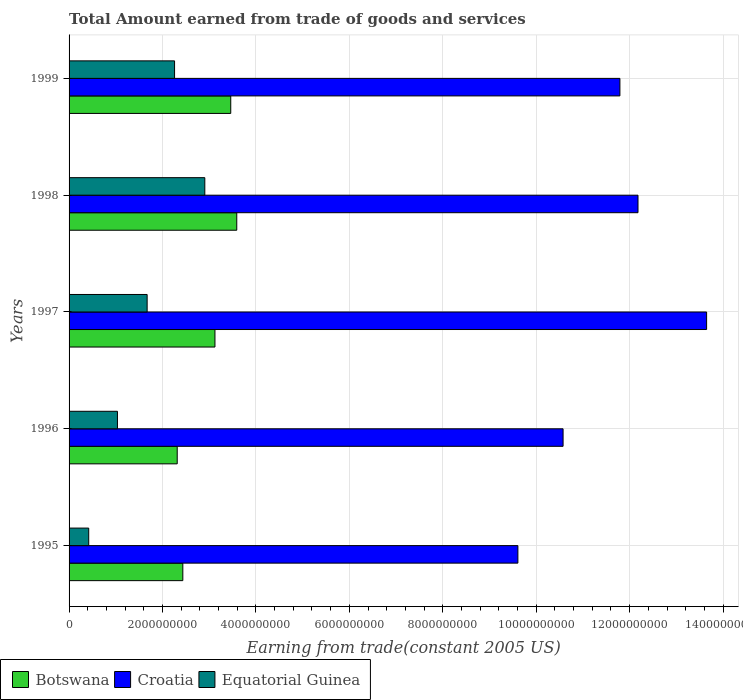How many different coloured bars are there?
Your answer should be very brief. 3. Are the number of bars on each tick of the Y-axis equal?
Your answer should be compact. Yes. What is the label of the 1st group of bars from the top?
Keep it short and to the point. 1999. What is the total amount earned by trading goods and services in Croatia in 1999?
Keep it short and to the point. 1.18e+1. Across all years, what is the maximum total amount earned by trading goods and services in Botswana?
Your answer should be compact. 3.59e+09. Across all years, what is the minimum total amount earned by trading goods and services in Equatorial Guinea?
Provide a short and direct response. 4.21e+08. In which year was the total amount earned by trading goods and services in Equatorial Guinea maximum?
Provide a succinct answer. 1998. In which year was the total amount earned by trading goods and services in Croatia minimum?
Provide a short and direct response. 1995. What is the total total amount earned by trading goods and services in Botswana in the graph?
Provide a succinct answer. 1.49e+1. What is the difference between the total amount earned by trading goods and services in Equatorial Guinea in 1998 and that in 1999?
Offer a very short reply. 6.48e+08. What is the difference between the total amount earned by trading goods and services in Botswana in 1996 and the total amount earned by trading goods and services in Croatia in 1998?
Your answer should be very brief. -9.86e+09. What is the average total amount earned by trading goods and services in Croatia per year?
Provide a succinct answer. 1.16e+1. In the year 1997, what is the difference between the total amount earned by trading goods and services in Botswana and total amount earned by trading goods and services in Croatia?
Your answer should be very brief. -1.05e+1. What is the ratio of the total amount earned by trading goods and services in Croatia in 1996 to that in 1997?
Provide a succinct answer. 0.77. Is the total amount earned by trading goods and services in Equatorial Guinea in 1997 less than that in 1998?
Ensure brevity in your answer.  Yes. Is the difference between the total amount earned by trading goods and services in Botswana in 1995 and 1999 greater than the difference between the total amount earned by trading goods and services in Croatia in 1995 and 1999?
Make the answer very short. Yes. What is the difference between the highest and the second highest total amount earned by trading goods and services in Equatorial Guinea?
Offer a very short reply. 6.48e+08. What is the difference between the highest and the lowest total amount earned by trading goods and services in Botswana?
Offer a terse response. 1.27e+09. In how many years, is the total amount earned by trading goods and services in Croatia greater than the average total amount earned by trading goods and services in Croatia taken over all years?
Provide a succinct answer. 3. Is the sum of the total amount earned by trading goods and services in Equatorial Guinea in 1997 and 1999 greater than the maximum total amount earned by trading goods and services in Croatia across all years?
Offer a very short reply. No. What does the 2nd bar from the top in 1997 represents?
Make the answer very short. Croatia. What does the 2nd bar from the bottom in 1998 represents?
Your answer should be compact. Croatia. Is it the case that in every year, the sum of the total amount earned by trading goods and services in Equatorial Guinea and total amount earned by trading goods and services in Botswana is greater than the total amount earned by trading goods and services in Croatia?
Your answer should be very brief. No. How many bars are there?
Provide a short and direct response. 15. Are all the bars in the graph horizontal?
Make the answer very short. Yes. What is the difference between two consecutive major ticks on the X-axis?
Make the answer very short. 2.00e+09. Are the values on the major ticks of X-axis written in scientific E-notation?
Your response must be concise. No. Does the graph contain any zero values?
Offer a very short reply. No. What is the title of the graph?
Make the answer very short. Total Amount earned from trade of goods and services. What is the label or title of the X-axis?
Give a very brief answer. Earning from trade(constant 2005 US). What is the label or title of the Y-axis?
Keep it short and to the point. Years. What is the Earning from trade(constant 2005 US) in Botswana in 1995?
Your answer should be very brief. 2.44e+09. What is the Earning from trade(constant 2005 US) of Croatia in 1995?
Offer a very short reply. 9.61e+09. What is the Earning from trade(constant 2005 US) in Equatorial Guinea in 1995?
Your response must be concise. 4.21e+08. What is the Earning from trade(constant 2005 US) of Botswana in 1996?
Offer a very short reply. 2.32e+09. What is the Earning from trade(constant 2005 US) in Croatia in 1996?
Keep it short and to the point. 1.06e+1. What is the Earning from trade(constant 2005 US) of Equatorial Guinea in 1996?
Keep it short and to the point. 1.04e+09. What is the Earning from trade(constant 2005 US) in Botswana in 1997?
Provide a succinct answer. 3.12e+09. What is the Earning from trade(constant 2005 US) in Croatia in 1997?
Provide a short and direct response. 1.36e+1. What is the Earning from trade(constant 2005 US) in Equatorial Guinea in 1997?
Your answer should be very brief. 1.67e+09. What is the Earning from trade(constant 2005 US) in Botswana in 1998?
Offer a terse response. 3.59e+09. What is the Earning from trade(constant 2005 US) in Croatia in 1998?
Provide a succinct answer. 1.22e+1. What is the Earning from trade(constant 2005 US) of Equatorial Guinea in 1998?
Make the answer very short. 2.91e+09. What is the Earning from trade(constant 2005 US) in Botswana in 1999?
Ensure brevity in your answer.  3.46e+09. What is the Earning from trade(constant 2005 US) of Croatia in 1999?
Keep it short and to the point. 1.18e+1. What is the Earning from trade(constant 2005 US) of Equatorial Guinea in 1999?
Give a very brief answer. 2.26e+09. Across all years, what is the maximum Earning from trade(constant 2005 US) of Botswana?
Keep it short and to the point. 3.59e+09. Across all years, what is the maximum Earning from trade(constant 2005 US) of Croatia?
Ensure brevity in your answer.  1.36e+1. Across all years, what is the maximum Earning from trade(constant 2005 US) in Equatorial Guinea?
Give a very brief answer. 2.91e+09. Across all years, what is the minimum Earning from trade(constant 2005 US) in Botswana?
Keep it short and to the point. 2.32e+09. Across all years, what is the minimum Earning from trade(constant 2005 US) of Croatia?
Your response must be concise. 9.61e+09. Across all years, what is the minimum Earning from trade(constant 2005 US) in Equatorial Guinea?
Your answer should be very brief. 4.21e+08. What is the total Earning from trade(constant 2005 US) of Botswana in the graph?
Keep it short and to the point. 1.49e+1. What is the total Earning from trade(constant 2005 US) in Croatia in the graph?
Give a very brief answer. 5.78e+1. What is the total Earning from trade(constant 2005 US) of Equatorial Guinea in the graph?
Your response must be concise. 8.29e+09. What is the difference between the Earning from trade(constant 2005 US) in Botswana in 1995 and that in 1996?
Ensure brevity in your answer.  1.20e+08. What is the difference between the Earning from trade(constant 2005 US) in Croatia in 1995 and that in 1996?
Provide a succinct answer. -9.67e+08. What is the difference between the Earning from trade(constant 2005 US) in Equatorial Guinea in 1995 and that in 1996?
Offer a terse response. -6.15e+08. What is the difference between the Earning from trade(constant 2005 US) in Botswana in 1995 and that in 1997?
Your response must be concise. -6.88e+08. What is the difference between the Earning from trade(constant 2005 US) of Croatia in 1995 and that in 1997?
Give a very brief answer. -4.04e+09. What is the difference between the Earning from trade(constant 2005 US) of Equatorial Guinea in 1995 and that in 1997?
Your response must be concise. -1.25e+09. What is the difference between the Earning from trade(constant 2005 US) in Botswana in 1995 and that in 1998?
Offer a terse response. -1.15e+09. What is the difference between the Earning from trade(constant 2005 US) in Croatia in 1995 and that in 1998?
Your answer should be very brief. -2.57e+09. What is the difference between the Earning from trade(constant 2005 US) in Equatorial Guinea in 1995 and that in 1998?
Keep it short and to the point. -2.49e+09. What is the difference between the Earning from trade(constant 2005 US) of Botswana in 1995 and that in 1999?
Your answer should be compact. -1.03e+09. What is the difference between the Earning from trade(constant 2005 US) of Croatia in 1995 and that in 1999?
Offer a very short reply. -2.18e+09. What is the difference between the Earning from trade(constant 2005 US) of Equatorial Guinea in 1995 and that in 1999?
Offer a very short reply. -1.84e+09. What is the difference between the Earning from trade(constant 2005 US) in Botswana in 1996 and that in 1997?
Keep it short and to the point. -8.08e+08. What is the difference between the Earning from trade(constant 2005 US) in Croatia in 1996 and that in 1997?
Your answer should be compact. -3.07e+09. What is the difference between the Earning from trade(constant 2005 US) in Equatorial Guinea in 1996 and that in 1997?
Your answer should be compact. -6.36e+08. What is the difference between the Earning from trade(constant 2005 US) of Botswana in 1996 and that in 1998?
Offer a terse response. -1.27e+09. What is the difference between the Earning from trade(constant 2005 US) of Croatia in 1996 and that in 1998?
Offer a terse response. -1.60e+09. What is the difference between the Earning from trade(constant 2005 US) in Equatorial Guinea in 1996 and that in 1998?
Offer a terse response. -1.87e+09. What is the difference between the Earning from trade(constant 2005 US) of Botswana in 1996 and that in 1999?
Your answer should be very brief. -1.15e+09. What is the difference between the Earning from trade(constant 2005 US) of Croatia in 1996 and that in 1999?
Provide a succinct answer. -1.22e+09. What is the difference between the Earning from trade(constant 2005 US) of Equatorial Guinea in 1996 and that in 1999?
Offer a terse response. -1.22e+09. What is the difference between the Earning from trade(constant 2005 US) in Botswana in 1997 and that in 1998?
Offer a very short reply. -4.67e+08. What is the difference between the Earning from trade(constant 2005 US) in Croatia in 1997 and that in 1998?
Make the answer very short. 1.47e+09. What is the difference between the Earning from trade(constant 2005 US) of Equatorial Guinea in 1997 and that in 1998?
Provide a succinct answer. -1.23e+09. What is the difference between the Earning from trade(constant 2005 US) of Botswana in 1997 and that in 1999?
Provide a succinct answer. -3.38e+08. What is the difference between the Earning from trade(constant 2005 US) of Croatia in 1997 and that in 1999?
Give a very brief answer. 1.86e+09. What is the difference between the Earning from trade(constant 2005 US) in Equatorial Guinea in 1997 and that in 1999?
Your answer should be very brief. -5.87e+08. What is the difference between the Earning from trade(constant 2005 US) of Botswana in 1998 and that in 1999?
Ensure brevity in your answer.  1.29e+08. What is the difference between the Earning from trade(constant 2005 US) of Croatia in 1998 and that in 1999?
Your answer should be compact. 3.87e+08. What is the difference between the Earning from trade(constant 2005 US) of Equatorial Guinea in 1998 and that in 1999?
Give a very brief answer. 6.48e+08. What is the difference between the Earning from trade(constant 2005 US) in Botswana in 1995 and the Earning from trade(constant 2005 US) in Croatia in 1996?
Offer a very short reply. -8.14e+09. What is the difference between the Earning from trade(constant 2005 US) in Botswana in 1995 and the Earning from trade(constant 2005 US) in Equatorial Guinea in 1996?
Give a very brief answer. 1.40e+09. What is the difference between the Earning from trade(constant 2005 US) of Croatia in 1995 and the Earning from trade(constant 2005 US) of Equatorial Guinea in 1996?
Keep it short and to the point. 8.57e+09. What is the difference between the Earning from trade(constant 2005 US) of Botswana in 1995 and the Earning from trade(constant 2005 US) of Croatia in 1997?
Provide a succinct answer. -1.12e+1. What is the difference between the Earning from trade(constant 2005 US) in Botswana in 1995 and the Earning from trade(constant 2005 US) in Equatorial Guinea in 1997?
Ensure brevity in your answer.  7.64e+08. What is the difference between the Earning from trade(constant 2005 US) in Croatia in 1995 and the Earning from trade(constant 2005 US) in Equatorial Guinea in 1997?
Make the answer very short. 7.94e+09. What is the difference between the Earning from trade(constant 2005 US) in Botswana in 1995 and the Earning from trade(constant 2005 US) in Croatia in 1998?
Keep it short and to the point. -9.74e+09. What is the difference between the Earning from trade(constant 2005 US) of Botswana in 1995 and the Earning from trade(constant 2005 US) of Equatorial Guinea in 1998?
Offer a very short reply. -4.70e+08. What is the difference between the Earning from trade(constant 2005 US) in Croatia in 1995 and the Earning from trade(constant 2005 US) in Equatorial Guinea in 1998?
Your answer should be compact. 6.70e+09. What is the difference between the Earning from trade(constant 2005 US) of Botswana in 1995 and the Earning from trade(constant 2005 US) of Croatia in 1999?
Offer a very short reply. -9.36e+09. What is the difference between the Earning from trade(constant 2005 US) of Botswana in 1995 and the Earning from trade(constant 2005 US) of Equatorial Guinea in 1999?
Make the answer very short. 1.77e+08. What is the difference between the Earning from trade(constant 2005 US) of Croatia in 1995 and the Earning from trade(constant 2005 US) of Equatorial Guinea in 1999?
Your answer should be very brief. 7.35e+09. What is the difference between the Earning from trade(constant 2005 US) in Botswana in 1996 and the Earning from trade(constant 2005 US) in Croatia in 1997?
Give a very brief answer. -1.13e+1. What is the difference between the Earning from trade(constant 2005 US) of Botswana in 1996 and the Earning from trade(constant 2005 US) of Equatorial Guinea in 1997?
Provide a short and direct response. 6.44e+08. What is the difference between the Earning from trade(constant 2005 US) in Croatia in 1996 and the Earning from trade(constant 2005 US) in Equatorial Guinea in 1997?
Give a very brief answer. 8.90e+09. What is the difference between the Earning from trade(constant 2005 US) of Botswana in 1996 and the Earning from trade(constant 2005 US) of Croatia in 1998?
Provide a succinct answer. -9.86e+09. What is the difference between the Earning from trade(constant 2005 US) in Botswana in 1996 and the Earning from trade(constant 2005 US) in Equatorial Guinea in 1998?
Provide a short and direct response. -5.91e+08. What is the difference between the Earning from trade(constant 2005 US) of Croatia in 1996 and the Earning from trade(constant 2005 US) of Equatorial Guinea in 1998?
Ensure brevity in your answer.  7.67e+09. What is the difference between the Earning from trade(constant 2005 US) of Botswana in 1996 and the Earning from trade(constant 2005 US) of Croatia in 1999?
Your answer should be compact. -9.48e+09. What is the difference between the Earning from trade(constant 2005 US) in Botswana in 1996 and the Earning from trade(constant 2005 US) in Equatorial Guinea in 1999?
Offer a terse response. 5.70e+07. What is the difference between the Earning from trade(constant 2005 US) in Croatia in 1996 and the Earning from trade(constant 2005 US) in Equatorial Guinea in 1999?
Your answer should be very brief. 8.32e+09. What is the difference between the Earning from trade(constant 2005 US) of Botswana in 1997 and the Earning from trade(constant 2005 US) of Croatia in 1998?
Offer a very short reply. -9.06e+09. What is the difference between the Earning from trade(constant 2005 US) of Botswana in 1997 and the Earning from trade(constant 2005 US) of Equatorial Guinea in 1998?
Provide a succinct answer. 2.17e+08. What is the difference between the Earning from trade(constant 2005 US) of Croatia in 1997 and the Earning from trade(constant 2005 US) of Equatorial Guinea in 1998?
Offer a terse response. 1.07e+1. What is the difference between the Earning from trade(constant 2005 US) of Botswana in 1997 and the Earning from trade(constant 2005 US) of Croatia in 1999?
Provide a short and direct response. -8.67e+09. What is the difference between the Earning from trade(constant 2005 US) in Botswana in 1997 and the Earning from trade(constant 2005 US) in Equatorial Guinea in 1999?
Your answer should be compact. 8.65e+08. What is the difference between the Earning from trade(constant 2005 US) in Croatia in 1997 and the Earning from trade(constant 2005 US) in Equatorial Guinea in 1999?
Give a very brief answer. 1.14e+1. What is the difference between the Earning from trade(constant 2005 US) of Botswana in 1998 and the Earning from trade(constant 2005 US) of Croatia in 1999?
Give a very brief answer. -8.20e+09. What is the difference between the Earning from trade(constant 2005 US) of Botswana in 1998 and the Earning from trade(constant 2005 US) of Equatorial Guinea in 1999?
Give a very brief answer. 1.33e+09. What is the difference between the Earning from trade(constant 2005 US) in Croatia in 1998 and the Earning from trade(constant 2005 US) in Equatorial Guinea in 1999?
Offer a very short reply. 9.92e+09. What is the average Earning from trade(constant 2005 US) of Botswana per year?
Make the answer very short. 2.98e+09. What is the average Earning from trade(constant 2005 US) of Croatia per year?
Make the answer very short. 1.16e+1. What is the average Earning from trade(constant 2005 US) in Equatorial Guinea per year?
Provide a short and direct response. 1.66e+09. In the year 1995, what is the difference between the Earning from trade(constant 2005 US) in Botswana and Earning from trade(constant 2005 US) in Croatia?
Offer a terse response. -7.17e+09. In the year 1995, what is the difference between the Earning from trade(constant 2005 US) in Botswana and Earning from trade(constant 2005 US) in Equatorial Guinea?
Provide a succinct answer. 2.01e+09. In the year 1995, what is the difference between the Earning from trade(constant 2005 US) in Croatia and Earning from trade(constant 2005 US) in Equatorial Guinea?
Provide a succinct answer. 9.19e+09. In the year 1996, what is the difference between the Earning from trade(constant 2005 US) in Botswana and Earning from trade(constant 2005 US) in Croatia?
Your response must be concise. -8.26e+09. In the year 1996, what is the difference between the Earning from trade(constant 2005 US) of Botswana and Earning from trade(constant 2005 US) of Equatorial Guinea?
Offer a very short reply. 1.28e+09. In the year 1996, what is the difference between the Earning from trade(constant 2005 US) of Croatia and Earning from trade(constant 2005 US) of Equatorial Guinea?
Provide a succinct answer. 9.54e+09. In the year 1997, what is the difference between the Earning from trade(constant 2005 US) of Botswana and Earning from trade(constant 2005 US) of Croatia?
Make the answer very short. -1.05e+1. In the year 1997, what is the difference between the Earning from trade(constant 2005 US) of Botswana and Earning from trade(constant 2005 US) of Equatorial Guinea?
Make the answer very short. 1.45e+09. In the year 1997, what is the difference between the Earning from trade(constant 2005 US) of Croatia and Earning from trade(constant 2005 US) of Equatorial Guinea?
Offer a terse response. 1.20e+1. In the year 1998, what is the difference between the Earning from trade(constant 2005 US) of Botswana and Earning from trade(constant 2005 US) of Croatia?
Provide a short and direct response. -8.59e+09. In the year 1998, what is the difference between the Earning from trade(constant 2005 US) of Botswana and Earning from trade(constant 2005 US) of Equatorial Guinea?
Provide a succinct answer. 6.84e+08. In the year 1998, what is the difference between the Earning from trade(constant 2005 US) of Croatia and Earning from trade(constant 2005 US) of Equatorial Guinea?
Make the answer very short. 9.27e+09. In the year 1999, what is the difference between the Earning from trade(constant 2005 US) of Botswana and Earning from trade(constant 2005 US) of Croatia?
Ensure brevity in your answer.  -8.33e+09. In the year 1999, what is the difference between the Earning from trade(constant 2005 US) in Botswana and Earning from trade(constant 2005 US) in Equatorial Guinea?
Provide a short and direct response. 1.20e+09. In the year 1999, what is the difference between the Earning from trade(constant 2005 US) of Croatia and Earning from trade(constant 2005 US) of Equatorial Guinea?
Provide a short and direct response. 9.53e+09. What is the ratio of the Earning from trade(constant 2005 US) in Botswana in 1995 to that in 1996?
Offer a very short reply. 1.05. What is the ratio of the Earning from trade(constant 2005 US) of Croatia in 1995 to that in 1996?
Your answer should be very brief. 0.91. What is the ratio of the Earning from trade(constant 2005 US) in Equatorial Guinea in 1995 to that in 1996?
Ensure brevity in your answer.  0.41. What is the ratio of the Earning from trade(constant 2005 US) in Botswana in 1995 to that in 1997?
Give a very brief answer. 0.78. What is the ratio of the Earning from trade(constant 2005 US) in Croatia in 1995 to that in 1997?
Provide a short and direct response. 0.7. What is the ratio of the Earning from trade(constant 2005 US) of Equatorial Guinea in 1995 to that in 1997?
Give a very brief answer. 0.25. What is the ratio of the Earning from trade(constant 2005 US) in Botswana in 1995 to that in 1998?
Offer a terse response. 0.68. What is the ratio of the Earning from trade(constant 2005 US) of Croatia in 1995 to that in 1998?
Keep it short and to the point. 0.79. What is the ratio of the Earning from trade(constant 2005 US) of Equatorial Guinea in 1995 to that in 1998?
Keep it short and to the point. 0.14. What is the ratio of the Earning from trade(constant 2005 US) in Botswana in 1995 to that in 1999?
Your response must be concise. 0.7. What is the ratio of the Earning from trade(constant 2005 US) in Croatia in 1995 to that in 1999?
Offer a very short reply. 0.81. What is the ratio of the Earning from trade(constant 2005 US) in Equatorial Guinea in 1995 to that in 1999?
Make the answer very short. 0.19. What is the ratio of the Earning from trade(constant 2005 US) in Botswana in 1996 to that in 1997?
Your response must be concise. 0.74. What is the ratio of the Earning from trade(constant 2005 US) of Croatia in 1996 to that in 1997?
Ensure brevity in your answer.  0.77. What is the ratio of the Earning from trade(constant 2005 US) of Equatorial Guinea in 1996 to that in 1997?
Your answer should be compact. 0.62. What is the ratio of the Earning from trade(constant 2005 US) in Botswana in 1996 to that in 1998?
Your answer should be very brief. 0.64. What is the ratio of the Earning from trade(constant 2005 US) of Croatia in 1996 to that in 1998?
Offer a terse response. 0.87. What is the ratio of the Earning from trade(constant 2005 US) of Equatorial Guinea in 1996 to that in 1998?
Your answer should be very brief. 0.36. What is the ratio of the Earning from trade(constant 2005 US) in Botswana in 1996 to that in 1999?
Offer a very short reply. 0.67. What is the ratio of the Earning from trade(constant 2005 US) in Croatia in 1996 to that in 1999?
Offer a terse response. 0.9. What is the ratio of the Earning from trade(constant 2005 US) in Equatorial Guinea in 1996 to that in 1999?
Keep it short and to the point. 0.46. What is the ratio of the Earning from trade(constant 2005 US) of Botswana in 1997 to that in 1998?
Ensure brevity in your answer.  0.87. What is the ratio of the Earning from trade(constant 2005 US) of Croatia in 1997 to that in 1998?
Your answer should be very brief. 1.12. What is the ratio of the Earning from trade(constant 2005 US) of Equatorial Guinea in 1997 to that in 1998?
Keep it short and to the point. 0.58. What is the ratio of the Earning from trade(constant 2005 US) in Botswana in 1997 to that in 1999?
Make the answer very short. 0.9. What is the ratio of the Earning from trade(constant 2005 US) in Croatia in 1997 to that in 1999?
Provide a succinct answer. 1.16. What is the ratio of the Earning from trade(constant 2005 US) of Equatorial Guinea in 1997 to that in 1999?
Offer a terse response. 0.74. What is the ratio of the Earning from trade(constant 2005 US) in Botswana in 1998 to that in 1999?
Offer a terse response. 1.04. What is the ratio of the Earning from trade(constant 2005 US) in Croatia in 1998 to that in 1999?
Offer a terse response. 1.03. What is the ratio of the Earning from trade(constant 2005 US) of Equatorial Guinea in 1998 to that in 1999?
Make the answer very short. 1.29. What is the difference between the highest and the second highest Earning from trade(constant 2005 US) of Botswana?
Offer a terse response. 1.29e+08. What is the difference between the highest and the second highest Earning from trade(constant 2005 US) in Croatia?
Make the answer very short. 1.47e+09. What is the difference between the highest and the second highest Earning from trade(constant 2005 US) in Equatorial Guinea?
Provide a succinct answer. 6.48e+08. What is the difference between the highest and the lowest Earning from trade(constant 2005 US) of Botswana?
Offer a terse response. 1.27e+09. What is the difference between the highest and the lowest Earning from trade(constant 2005 US) in Croatia?
Your answer should be very brief. 4.04e+09. What is the difference between the highest and the lowest Earning from trade(constant 2005 US) in Equatorial Guinea?
Offer a terse response. 2.49e+09. 